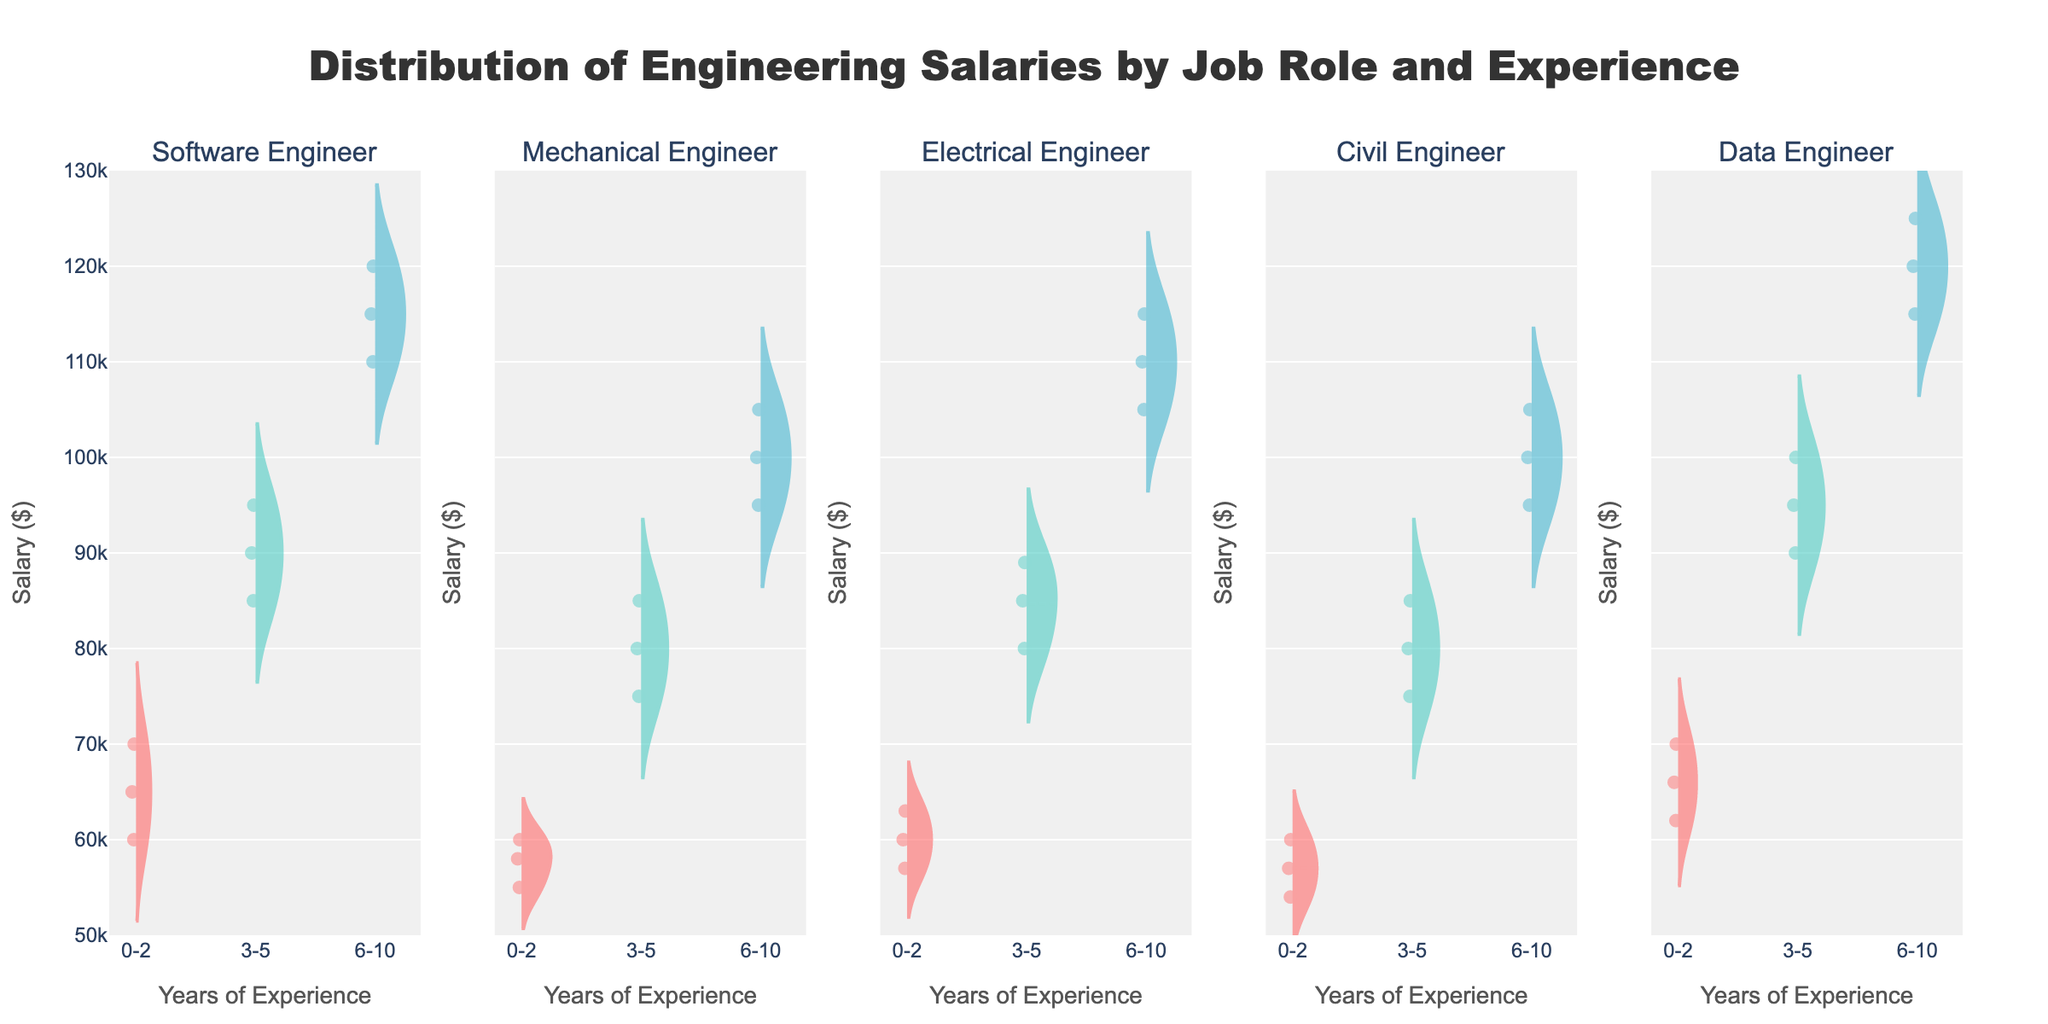What is the title of the plot? The title is displayed at the top of the plot. It uses larger and bold text to stand out.
Answer: Distribution of Engineering Salaries by Job Role and Experience What is the range of salaries shown on the y-axis of the plot? The y-axis displays salaries and is labeled from $50,000 to $130,000 as indicated by the axis ticks.
Answer: $50,000 to $130,000 Which job role has the highest average salary for the 6-10 years of experience category? By observing the position of the mean lines in the violins, we can see that the Data Engineer role has the highest position, indicating the highest average salary in this category.
Answer: Data Engineer Do Electrical Engineers or Civil Engineers have a wider distribution of salaries in the 3-5 years of experience category? The width of the violin plots indicates the distribution spread. Electrical Engineers have a wider violin plot in the 3-5 years of experience category compared to Civil Engineers.
Answer: Electrical Engineers Which job role shows the narrowest distribution of salaries in the 0-2 years of experience category? The narrowest distribution in the 0-2 years category corresponds to the plot with the smallest width. This is evident for Data Engineers.
Answer: Data Engineer What is the approximate median salary for Mechanical Engineers with 6-10 years of experience? The median salary is indicated by the white dot in the center of the violin plot. For Mechanical Engineers with 6-10 years, this dot is around $100,000.
Answer: $100,000 Does the violin plot for Software Engineers with 0-2 years of experience appear higher or lower than for Mechanical Engineers with the same experience? By comparing the vertical positions of the plots, Software Engineers have a higher violin plot than Mechanical Engineers for 0-2 years of experience.
Answer: Higher Which experience category has the smallest spread of salaries for Civil Engineers? The spread of salaries is indicated by the width of the violin plot. The 0-2 years category for Civil Engineers has the smallest spread.
Answer: 0-2 years How do the distributions of salaries for Software Engineers compare between the 3-5 and 6-10 years of experience categories? Comparing the two violin plots for Software Engineers, the 6-10 years category shows both a higher mean and a wider distribution compared to the 3-5 years category.
Answer: 6-10 years has a higher mean and wider distribution What is one notable difference between the salary distributions of Data Engineers and Electrical Engineers for the 0-2 years of experience? The notable difference is that Data Engineers have a slightly higher and narrower distribution compared to Electrical Engineers, indicating higher starting salaries and less variability.
Answer: Data Engineers have higher and narrower distributions 